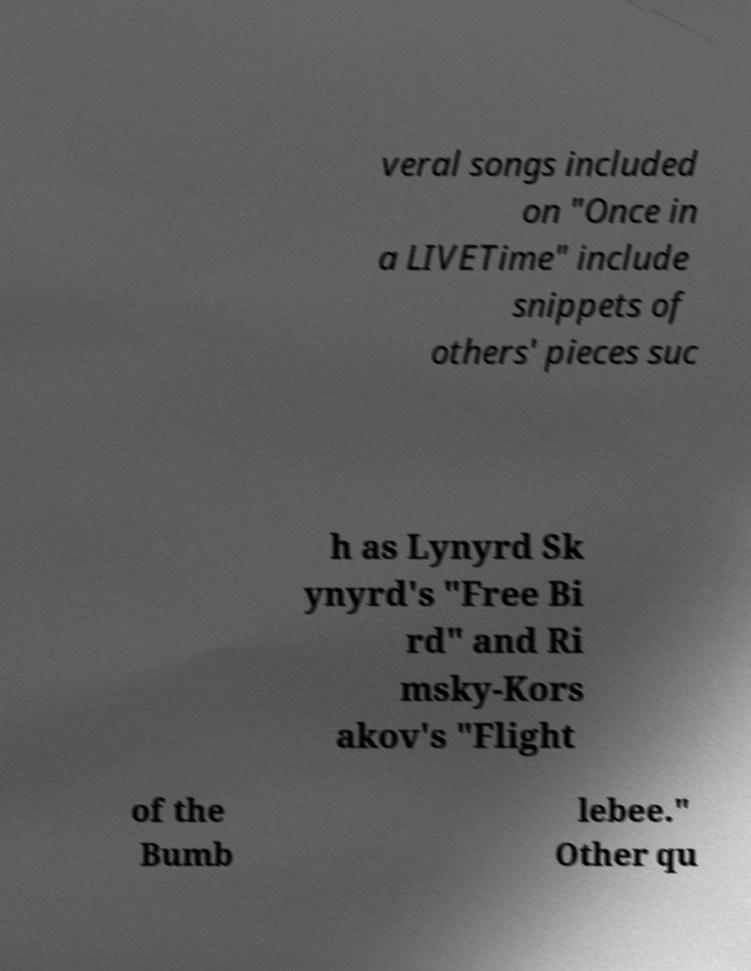Could you assist in decoding the text presented in this image and type it out clearly? veral songs included on "Once in a LIVETime" include snippets of others' pieces suc h as Lynyrd Sk ynyrd's "Free Bi rd" and Ri msky-Kors akov's "Flight of the Bumb lebee." Other qu 